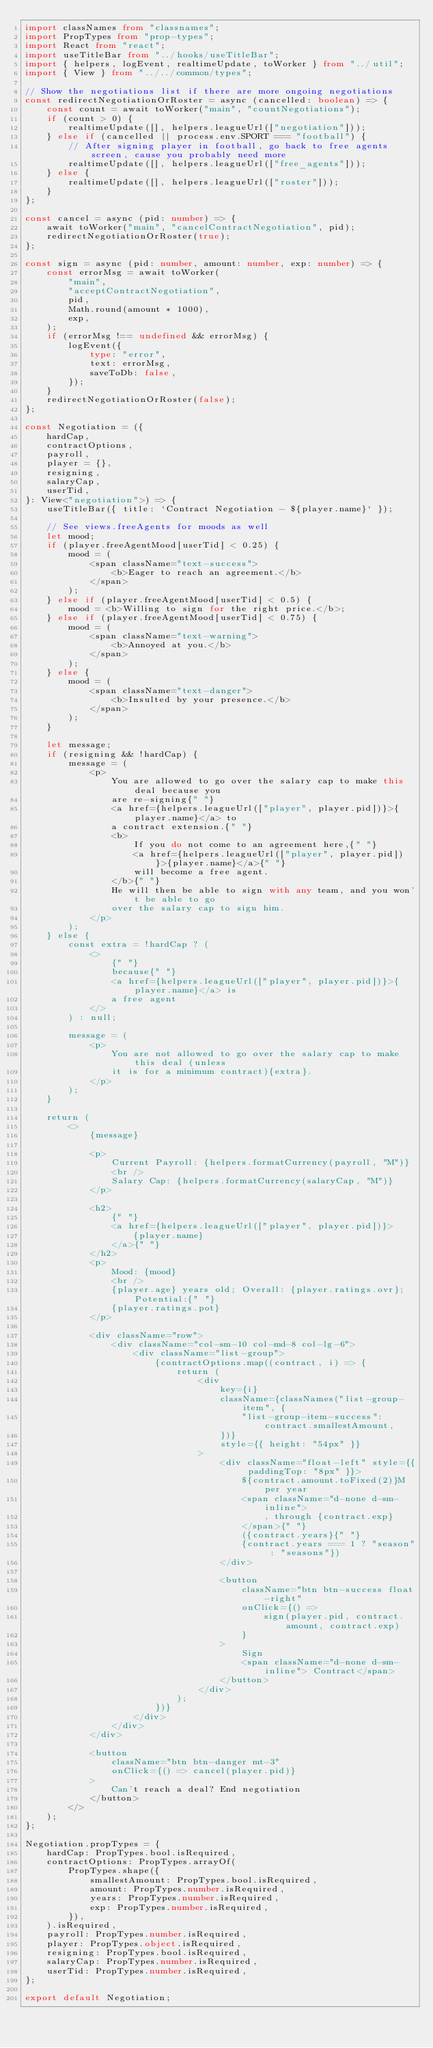<code> <loc_0><loc_0><loc_500><loc_500><_TypeScript_>import classNames from "classnames";
import PropTypes from "prop-types";
import React from "react";
import useTitleBar from "../hooks/useTitleBar";
import { helpers, logEvent, realtimeUpdate, toWorker } from "../util";
import { View } from "../../common/types";

// Show the negotiations list if there are more ongoing negotiations
const redirectNegotiationOrRoster = async (cancelled: boolean) => {
	const count = await toWorker("main", "countNegotiations");
	if (count > 0) {
		realtimeUpdate([], helpers.leagueUrl(["negotiation"]));
	} else if (cancelled || process.env.SPORT === "football") {
		// After signing player in football, go back to free agents screen, cause you probably need more
		realtimeUpdate([], helpers.leagueUrl(["free_agents"]));
	} else {
		realtimeUpdate([], helpers.leagueUrl(["roster"]));
	}
};

const cancel = async (pid: number) => {
	await toWorker("main", "cancelContractNegotiation", pid);
	redirectNegotiationOrRoster(true);
};

const sign = async (pid: number, amount: number, exp: number) => {
	const errorMsg = await toWorker(
		"main",
		"acceptContractNegotiation",
		pid,
		Math.round(amount * 1000),
		exp,
	);
	if (errorMsg !== undefined && errorMsg) {
		logEvent({
			type: "error",
			text: errorMsg,
			saveToDb: false,
		});
	}
	redirectNegotiationOrRoster(false);
};

const Negotiation = ({
	hardCap,
	contractOptions,
	payroll,
	player = {},
	resigning,
	salaryCap,
	userTid,
}: View<"negotiation">) => {
	useTitleBar({ title: `Contract Negotiation - ${player.name}` });

	// See views.freeAgents for moods as well
	let mood;
	if (player.freeAgentMood[userTid] < 0.25) {
		mood = (
			<span className="text-success">
				<b>Eager to reach an agreement.</b>
			</span>
		);
	} else if (player.freeAgentMood[userTid] < 0.5) {
		mood = <b>Willing to sign for the right price.</b>;
	} else if (player.freeAgentMood[userTid] < 0.75) {
		mood = (
			<span className="text-warning">
				<b>Annoyed at you.</b>
			</span>
		);
	} else {
		mood = (
			<span className="text-danger">
				<b>Insulted by your presence.</b>
			</span>
		);
	}

	let message;
	if (resigning && !hardCap) {
		message = (
			<p>
				You are allowed to go over the salary cap to make this deal because you
				are re-signing{" "}
				<a href={helpers.leagueUrl(["player", player.pid])}>{player.name}</a> to
				a contract extension.{" "}
				<b>
					If you do not come to an agreement here,{" "}
					<a href={helpers.leagueUrl(["player", player.pid])}>{player.name}</a>{" "}
					will become a free agent.
				</b>{" "}
				He will then be able to sign with any team, and you won't be able to go
				over the salary cap to sign him.
			</p>
		);
	} else {
		const extra = !hardCap ? (
			<>
				{" "}
				because{" "}
				<a href={helpers.leagueUrl(["player", player.pid])}>{player.name}</a> is
				a free agent
			</>
		) : null;

		message = (
			<p>
				You are not allowed to go over the salary cap to make this deal (unless
				it is for a minimum contract){extra}.
			</p>
		);
	}

	return (
		<>
			{message}

			<p>
				Current Payroll: {helpers.formatCurrency(payroll, "M")}
				<br />
				Salary Cap: {helpers.formatCurrency(salaryCap, "M")}
			</p>

			<h2>
				{" "}
				<a href={helpers.leagueUrl(["player", player.pid])}>
					{player.name}
				</a>{" "}
			</h2>
			<p>
				Mood: {mood}
				<br />
				{player.age} years old; Overall: {player.ratings.ovr}; Potential:{" "}
				{player.ratings.pot}
			</p>

			<div className="row">
				<div className="col-sm-10 col-md-8 col-lg-6">
					<div className="list-group">
						{contractOptions.map((contract, i) => {
							return (
								<div
									key={i}
									className={classNames("list-group-item", {
										"list-group-item-success": contract.smallestAmount,
									})}
									style={{ height: "54px" }}
								>
									<div className="float-left" style={{ paddingTop: "8px" }}>
										${contract.amount.toFixed(2)}M per year
										<span className="d-none d-sm-inline">
											, through {contract.exp}
										</span>{" "}
										({contract.years}{" "}
										{contract.years === 1 ? "season" : "seasons"})
									</div>

									<button
										className="btn btn-success float-right"
										onClick={() =>
											sign(player.pid, contract.amount, contract.exp)
										}
									>
										Sign
										<span className="d-none d-sm-inline"> Contract</span>
									</button>
								</div>
							);
						})}
					</div>
				</div>
			</div>

			<button
				className="btn btn-danger mt-3"
				onClick={() => cancel(player.pid)}
			>
				Can't reach a deal? End negotiation
			</button>
		</>
	);
};

Negotiation.propTypes = {
	hardCap: PropTypes.bool.isRequired,
	contractOptions: PropTypes.arrayOf(
		PropTypes.shape({
			smallestAmount: PropTypes.bool.isRequired,
			amount: PropTypes.number.isRequired,
			years: PropTypes.number.isRequired,
			exp: PropTypes.number.isRequired,
		}),
	).isRequired,
	payroll: PropTypes.number.isRequired,
	player: PropTypes.object.isRequired,
	resigning: PropTypes.bool.isRequired,
	salaryCap: PropTypes.number.isRequired,
	userTid: PropTypes.number.isRequired,
};

export default Negotiation;
</code> 